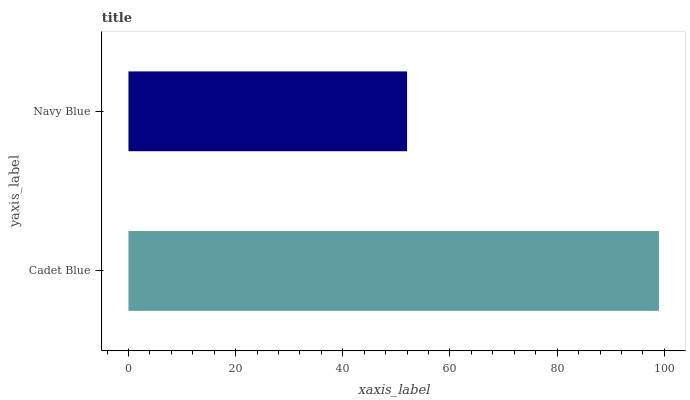Is Navy Blue the minimum?
Answer yes or no. Yes. Is Cadet Blue the maximum?
Answer yes or no. Yes. Is Navy Blue the maximum?
Answer yes or no. No. Is Cadet Blue greater than Navy Blue?
Answer yes or no. Yes. Is Navy Blue less than Cadet Blue?
Answer yes or no. Yes. Is Navy Blue greater than Cadet Blue?
Answer yes or no. No. Is Cadet Blue less than Navy Blue?
Answer yes or no. No. Is Cadet Blue the high median?
Answer yes or no. Yes. Is Navy Blue the low median?
Answer yes or no. Yes. Is Navy Blue the high median?
Answer yes or no. No. Is Cadet Blue the low median?
Answer yes or no. No. 